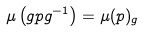<formula> <loc_0><loc_0><loc_500><loc_500>\mu \left ( g p g ^ { - 1 } \right ) = \mu ( p ) _ { g }</formula> 